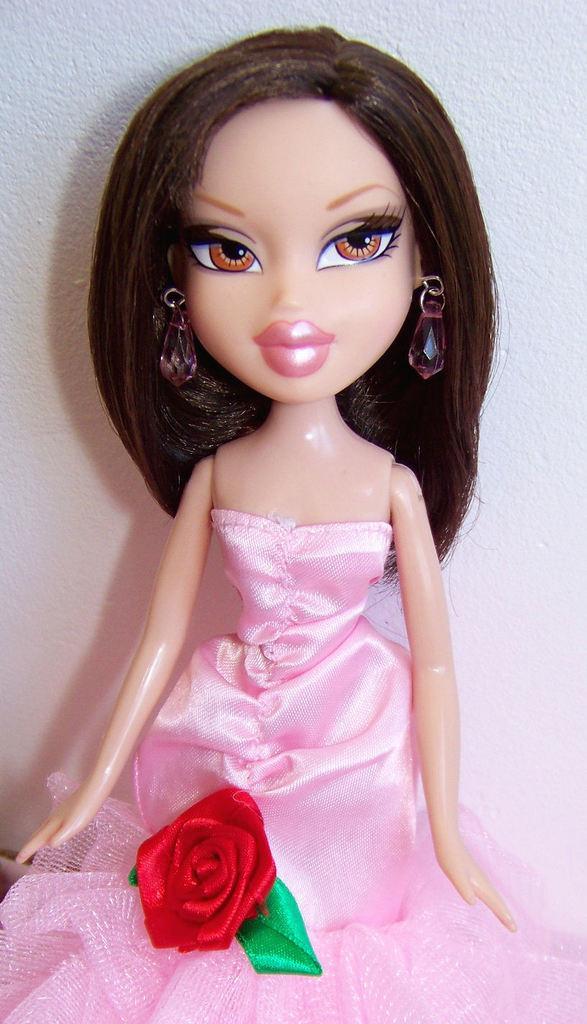Describe this image in one or two sentences. In this image there is a toy girl wearing pink gown. On the gown there is a red rose. In the background there is white wall. 